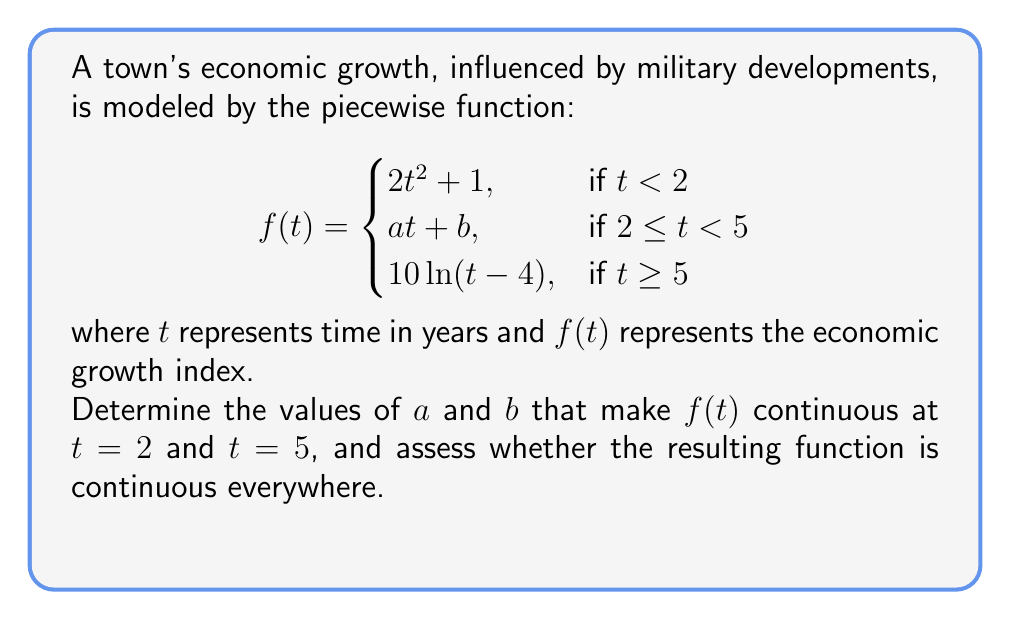What is the answer to this math problem? Let's approach this step-by-step:

1) For $f(t)$ to be continuous at $t = 2$, the limit from the left must equal the limit from the right:

   $\lim_{t \to 2^-} f(t) = \lim_{t \to 2^+} f(t)$
   $2(2)^2 + 1 = a(2) + b$
   $9 = 2a + b$ ... (Equation 1)

2) For $f(t)$ to be continuous at $t = 5$, we apply the same principle:

   $\lim_{t \to 5^-} f(t) = \lim_{t \to 5^+} f(t)$
   $5a + b = 10\ln(1)$
   $5a + b = 0$ ... (Equation 2)

3) Solve the system of equations:
   Multiply Equation 1 by 5 and Equation 2 by -2:
   
   $45 = 10a + 5b$
   $0 = -10a - 2b$
   
   Adding these equations:
   $45 = 3b$
   $b = 15$

4) Substitute $b = 15$ into Equation 1:
   $9 = 2a + 15$
   $-6 = 2a$
   $a = -3$

5) Therefore, $a = -3$ and $b = 15$

6) To check if $f(t)$ is continuous everywhere, we need to verify:
   - It's continuous on $(-\infty, 2)$, $(2, 5)$, and $(5, \infty)$ (which it is, as these are all elementary functions)
   - It's continuous at $t = 2$ and $t = 5$ (which we've ensured)
   - The limits exist as $t$ approaches $\infty$ and $-\infty$

   As $t \to -\infty$, $f(t) \to \infty$
   As $t \to \infty$, $f(t) \to \infty$

   Therefore, $f(t)$ is continuous everywhere.
Answer: $a = -3$, $b = 15$; $f(t)$ is continuous everywhere. 